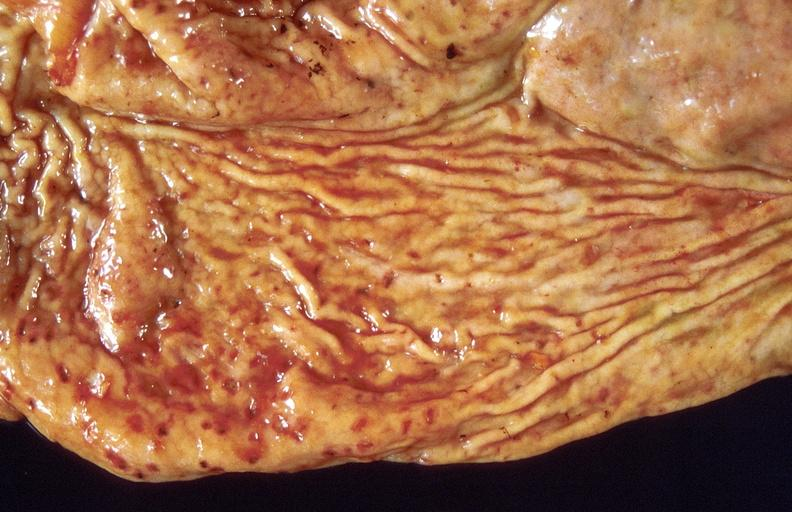what does this image show?
Answer the question using a single word or phrase. Stress ulcers 